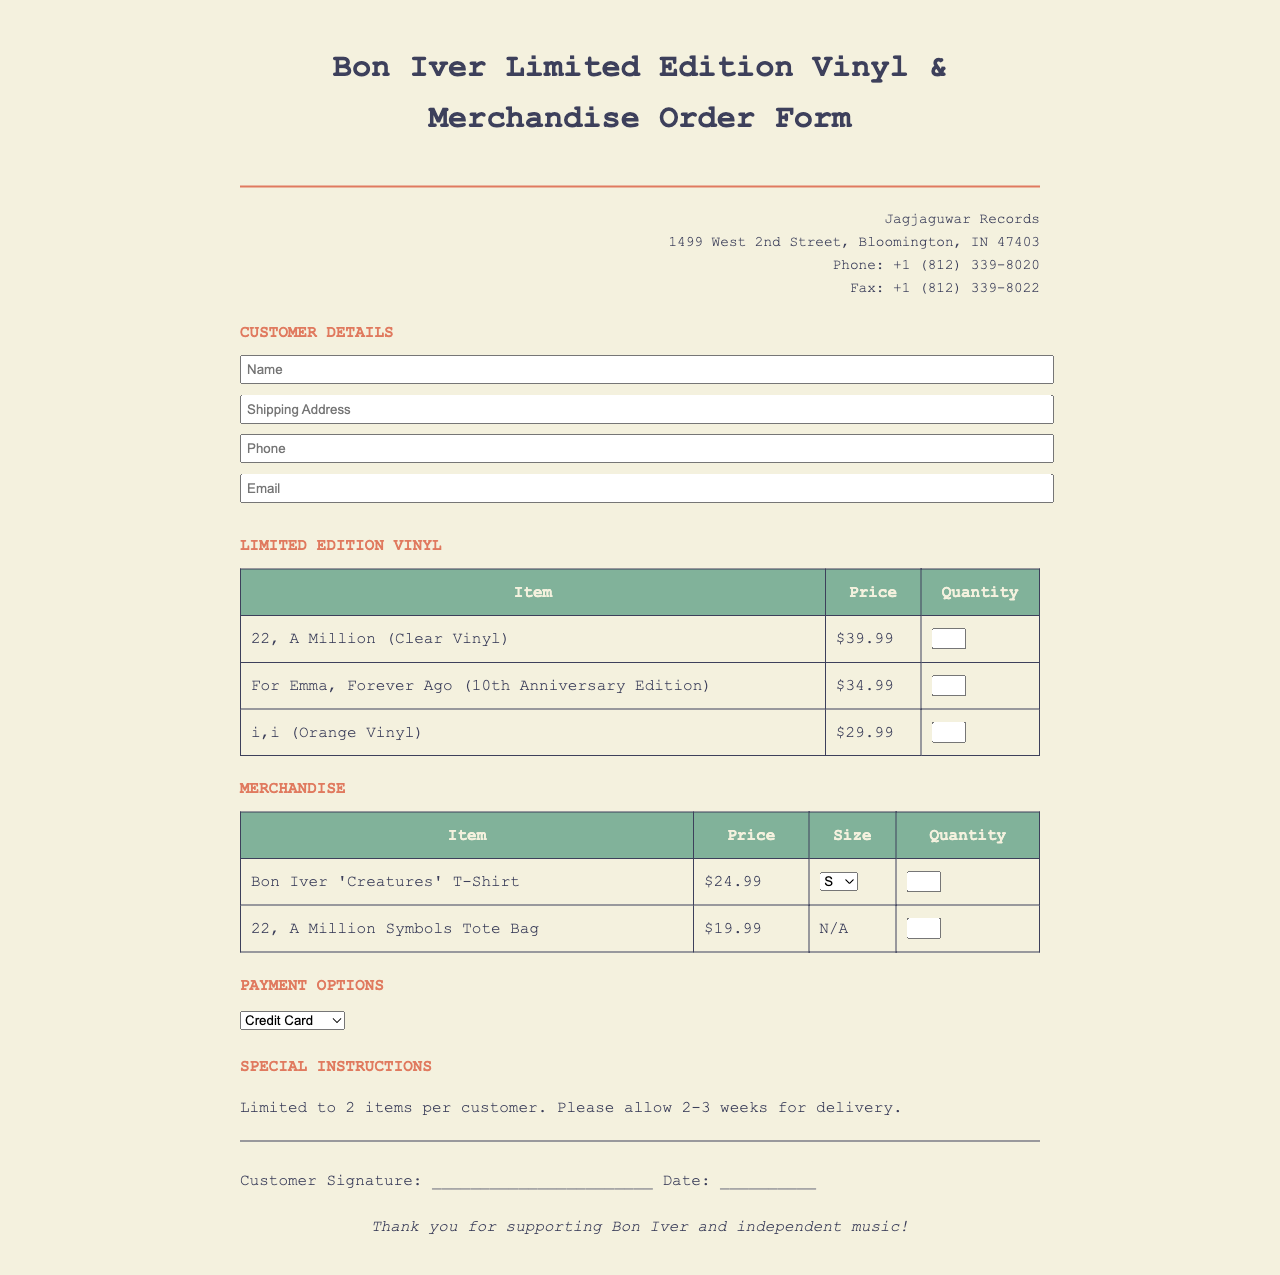What is the title of the document? The title of the document is prominently displayed at the top of the form, specifying the type of order form it is.
Answer: Bon Iver Limited Edition Vinyl & Merchandise Order Form What is the price of "For Emma, Forever Ago (10th Anniversary Edition)"? The price is listed in the table for limited edition vinyl under its corresponding item row.
Answer: $34.99 What are the payment options available on the form? Payment options are listed in a dropdown section, providing the choices available for customers.
Answer: Credit Card, PayPal, Bank Transfer What is the maximum quantity per item that a customer can order? The document mentions a limit on the quantity of items a customer can purchase in the special instructions section.
Answer: 2 What is the company name listed on the document? The company name appears in the header section, which indicates who the order form is associated with.
Answer: Jagjaguwar Records What is the shipping address town? The shipping address is provided in the company information section, and the town is part of that address.
Answer: Bloomington What size options are available for the Bon Iver 'Creatures' T-Shirt? The available options are provided in a dropdown menu within the merchandise table.
Answer: S, M, L, XL What is the expected delivery time mentioned in the special instructions? The document specifies an estimated timeframe for delivery within the special instructions section.
Answer: 2-3 weeks 